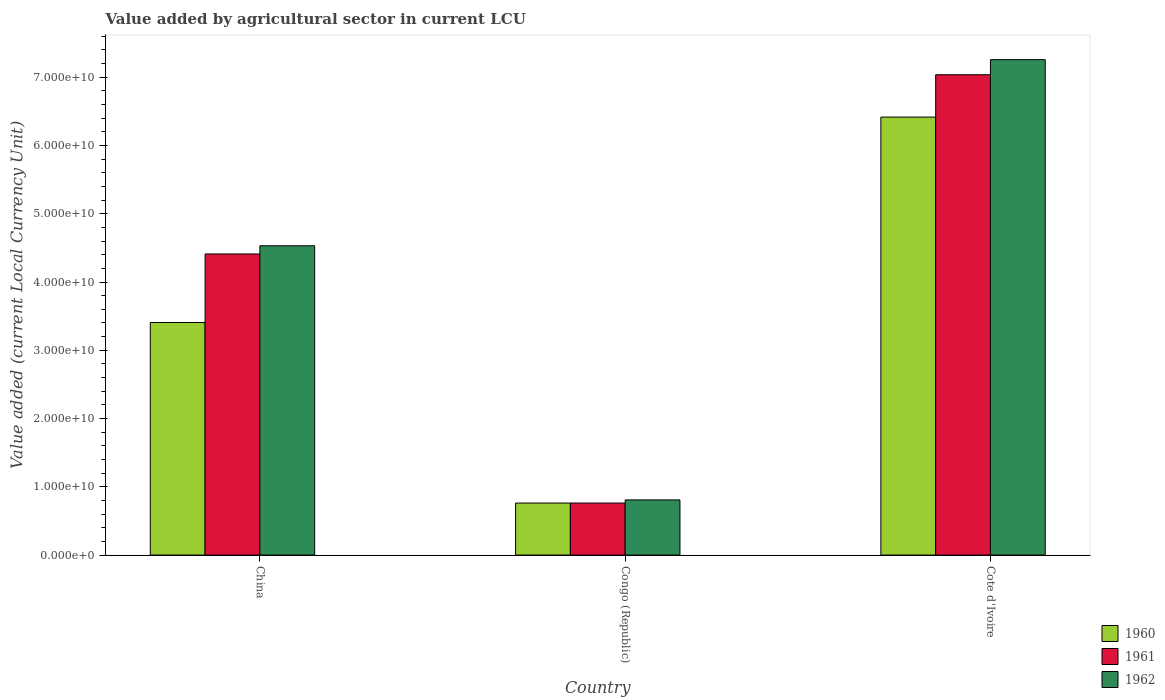How many different coloured bars are there?
Make the answer very short. 3. Are the number of bars per tick equal to the number of legend labels?
Make the answer very short. Yes. Are the number of bars on each tick of the X-axis equal?
Provide a succinct answer. Yes. How many bars are there on the 2nd tick from the right?
Provide a succinct answer. 3. What is the label of the 3rd group of bars from the left?
Your response must be concise. Cote d'Ivoire. In how many cases, is the number of bars for a given country not equal to the number of legend labels?
Ensure brevity in your answer.  0. What is the value added by agricultural sector in 1962 in Cote d'Ivoire?
Give a very brief answer. 7.26e+1. Across all countries, what is the maximum value added by agricultural sector in 1961?
Your answer should be very brief. 7.04e+1. Across all countries, what is the minimum value added by agricultural sector in 1960?
Provide a succinct answer. 7.62e+09. In which country was the value added by agricultural sector in 1961 maximum?
Offer a terse response. Cote d'Ivoire. In which country was the value added by agricultural sector in 1960 minimum?
Your response must be concise. Congo (Republic). What is the total value added by agricultural sector in 1960 in the graph?
Make the answer very short. 1.06e+11. What is the difference between the value added by agricultural sector in 1960 in China and that in Congo (Republic)?
Provide a succinct answer. 2.64e+1. What is the difference between the value added by agricultural sector in 1960 in Congo (Republic) and the value added by agricultural sector in 1961 in Cote d'Ivoire?
Provide a short and direct response. -6.27e+1. What is the average value added by agricultural sector in 1961 per country?
Your response must be concise. 4.07e+1. What is the difference between the value added by agricultural sector of/in 1961 and value added by agricultural sector of/in 1962 in Cote d'Ivoire?
Keep it short and to the point. -2.21e+09. In how many countries, is the value added by agricultural sector in 1961 greater than 36000000000 LCU?
Offer a very short reply. 2. What is the ratio of the value added by agricultural sector in 1961 in China to that in Cote d'Ivoire?
Give a very brief answer. 0.63. Is the difference between the value added by agricultural sector in 1961 in China and Congo (Republic) greater than the difference between the value added by agricultural sector in 1962 in China and Congo (Republic)?
Offer a terse response. No. What is the difference between the highest and the second highest value added by agricultural sector in 1962?
Your response must be concise. 6.45e+1. What is the difference between the highest and the lowest value added by agricultural sector in 1961?
Keep it short and to the point. 6.27e+1. Is the sum of the value added by agricultural sector in 1960 in China and Congo (Republic) greater than the maximum value added by agricultural sector in 1962 across all countries?
Your answer should be compact. No. What does the 1st bar from the left in China represents?
Provide a succinct answer. 1960. Is it the case that in every country, the sum of the value added by agricultural sector in 1962 and value added by agricultural sector in 1961 is greater than the value added by agricultural sector in 1960?
Provide a short and direct response. Yes. Are all the bars in the graph horizontal?
Ensure brevity in your answer.  No. What is the difference between two consecutive major ticks on the Y-axis?
Your response must be concise. 1.00e+1. Where does the legend appear in the graph?
Offer a terse response. Bottom right. What is the title of the graph?
Your answer should be compact. Value added by agricultural sector in current LCU. Does "2004" appear as one of the legend labels in the graph?
Provide a succinct answer. No. What is the label or title of the X-axis?
Keep it short and to the point. Country. What is the label or title of the Y-axis?
Provide a short and direct response. Value added (current Local Currency Unit). What is the Value added (current Local Currency Unit) in 1960 in China?
Provide a succinct answer. 3.41e+1. What is the Value added (current Local Currency Unit) of 1961 in China?
Provide a succinct answer. 4.41e+1. What is the Value added (current Local Currency Unit) of 1962 in China?
Make the answer very short. 4.53e+1. What is the Value added (current Local Currency Unit) of 1960 in Congo (Republic)?
Make the answer very short. 7.62e+09. What is the Value added (current Local Currency Unit) in 1961 in Congo (Republic)?
Give a very brief answer. 7.62e+09. What is the Value added (current Local Currency Unit) of 1962 in Congo (Republic)?
Keep it short and to the point. 8.08e+09. What is the Value added (current Local Currency Unit) of 1960 in Cote d'Ivoire?
Give a very brief answer. 6.42e+1. What is the Value added (current Local Currency Unit) of 1961 in Cote d'Ivoire?
Make the answer very short. 7.04e+1. What is the Value added (current Local Currency Unit) of 1962 in Cote d'Ivoire?
Your response must be concise. 7.26e+1. Across all countries, what is the maximum Value added (current Local Currency Unit) of 1960?
Offer a very short reply. 6.42e+1. Across all countries, what is the maximum Value added (current Local Currency Unit) of 1961?
Keep it short and to the point. 7.04e+1. Across all countries, what is the maximum Value added (current Local Currency Unit) of 1962?
Ensure brevity in your answer.  7.26e+1. Across all countries, what is the minimum Value added (current Local Currency Unit) in 1960?
Your answer should be compact. 7.62e+09. Across all countries, what is the minimum Value added (current Local Currency Unit) of 1961?
Ensure brevity in your answer.  7.62e+09. Across all countries, what is the minimum Value added (current Local Currency Unit) of 1962?
Your response must be concise. 8.08e+09. What is the total Value added (current Local Currency Unit) in 1960 in the graph?
Keep it short and to the point. 1.06e+11. What is the total Value added (current Local Currency Unit) in 1961 in the graph?
Give a very brief answer. 1.22e+11. What is the total Value added (current Local Currency Unit) in 1962 in the graph?
Offer a terse response. 1.26e+11. What is the difference between the Value added (current Local Currency Unit) of 1960 in China and that in Congo (Republic)?
Your answer should be compact. 2.64e+1. What is the difference between the Value added (current Local Currency Unit) in 1961 in China and that in Congo (Republic)?
Give a very brief answer. 3.65e+1. What is the difference between the Value added (current Local Currency Unit) of 1962 in China and that in Congo (Republic)?
Give a very brief answer. 3.72e+1. What is the difference between the Value added (current Local Currency Unit) in 1960 in China and that in Cote d'Ivoire?
Your response must be concise. -3.01e+1. What is the difference between the Value added (current Local Currency Unit) of 1961 in China and that in Cote d'Ivoire?
Provide a short and direct response. -2.63e+1. What is the difference between the Value added (current Local Currency Unit) in 1962 in China and that in Cote d'Ivoire?
Give a very brief answer. -2.73e+1. What is the difference between the Value added (current Local Currency Unit) in 1960 in Congo (Republic) and that in Cote d'Ivoire?
Your response must be concise. -5.65e+1. What is the difference between the Value added (current Local Currency Unit) in 1961 in Congo (Republic) and that in Cote d'Ivoire?
Your answer should be very brief. -6.27e+1. What is the difference between the Value added (current Local Currency Unit) in 1962 in Congo (Republic) and that in Cote d'Ivoire?
Give a very brief answer. -6.45e+1. What is the difference between the Value added (current Local Currency Unit) in 1960 in China and the Value added (current Local Currency Unit) in 1961 in Congo (Republic)?
Offer a very short reply. 2.64e+1. What is the difference between the Value added (current Local Currency Unit) of 1960 in China and the Value added (current Local Currency Unit) of 1962 in Congo (Republic)?
Ensure brevity in your answer.  2.60e+1. What is the difference between the Value added (current Local Currency Unit) of 1961 in China and the Value added (current Local Currency Unit) of 1962 in Congo (Republic)?
Give a very brief answer. 3.60e+1. What is the difference between the Value added (current Local Currency Unit) of 1960 in China and the Value added (current Local Currency Unit) of 1961 in Cote d'Ivoire?
Provide a succinct answer. -3.63e+1. What is the difference between the Value added (current Local Currency Unit) in 1960 in China and the Value added (current Local Currency Unit) in 1962 in Cote d'Ivoire?
Ensure brevity in your answer.  -3.85e+1. What is the difference between the Value added (current Local Currency Unit) of 1961 in China and the Value added (current Local Currency Unit) of 1962 in Cote d'Ivoire?
Ensure brevity in your answer.  -2.85e+1. What is the difference between the Value added (current Local Currency Unit) of 1960 in Congo (Republic) and the Value added (current Local Currency Unit) of 1961 in Cote d'Ivoire?
Your answer should be very brief. -6.27e+1. What is the difference between the Value added (current Local Currency Unit) of 1960 in Congo (Republic) and the Value added (current Local Currency Unit) of 1962 in Cote d'Ivoire?
Keep it short and to the point. -6.50e+1. What is the difference between the Value added (current Local Currency Unit) of 1961 in Congo (Republic) and the Value added (current Local Currency Unit) of 1962 in Cote d'Ivoire?
Give a very brief answer. -6.50e+1. What is the average Value added (current Local Currency Unit) in 1960 per country?
Offer a terse response. 3.53e+1. What is the average Value added (current Local Currency Unit) in 1961 per country?
Your response must be concise. 4.07e+1. What is the average Value added (current Local Currency Unit) of 1962 per country?
Your answer should be compact. 4.20e+1. What is the difference between the Value added (current Local Currency Unit) of 1960 and Value added (current Local Currency Unit) of 1961 in China?
Your answer should be very brief. -1.00e+1. What is the difference between the Value added (current Local Currency Unit) in 1960 and Value added (current Local Currency Unit) in 1962 in China?
Provide a succinct answer. -1.12e+1. What is the difference between the Value added (current Local Currency Unit) of 1961 and Value added (current Local Currency Unit) of 1962 in China?
Keep it short and to the point. -1.20e+09. What is the difference between the Value added (current Local Currency Unit) in 1960 and Value added (current Local Currency Unit) in 1962 in Congo (Republic)?
Offer a very short reply. -4.57e+08. What is the difference between the Value added (current Local Currency Unit) in 1961 and Value added (current Local Currency Unit) in 1962 in Congo (Republic)?
Provide a short and direct response. -4.57e+08. What is the difference between the Value added (current Local Currency Unit) of 1960 and Value added (current Local Currency Unit) of 1961 in Cote d'Ivoire?
Give a very brief answer. -6.21e+09. What is the difference between the Value added (current Local Currency Unit) in 1960 and Value added (current Local Currency Unit) in 1962 in Cote d'Ivoire?
Your answer should be compact. -8.41e+09. What is the difference between the Value added (current Local Currency Unit) of 1961 and Value added (current Local Currency Unit) of 1962 in Cote d'Ivoire?
Offer a very short reply. -2.21e+09. What is the ratio of the Value added (current Local Currency Unit) in 1960 in China to that in Congo (Republic)?
Ensure brevity in your answer.  4.47. What is the ratio of the Value added (current Local Currency Unit) of 1961 in China to that in Congo (Republic)?
Keep it short and to the point. 5.79. What is the ratio of the Value added (current Local Currency Unit) of 1962 in China to that in Congo (Republic)?
Provide a succinct answer. 5.61. What is the ratio of the Value added (current Local Currency Unit) of 1960 in China to that in Cote d'Ivoire?
Give a very brief answer. 0.53. What is the ratio of the Value added (current Local Currency Unit) in 1961 in China to that in Cote d'Ivoire?
Provide a short and direct response. 0.63. What is the ratio of the Value added (current Local Currency Unit) in 1962 in China to that in Cote d'Ivoire?
Keep it short and to the point. 0.62. What is the ratio of the Value added (current Local Currency Unit) in 1960 in Congo (Republic) to that in Cote d'Ivoire?
Give a very brief answer. 0.12. What is the ratio of the Value added (current Local Currency Unit) of 1961 in Congo (Republic) to that in Cote d'Ivoire?
Your answer should be compact. 0.11. What is the ratio of the Value added (current Local Currency Unit) in 1962 in Congo (Republic) to that in Cote d'Ivoire?
Provide a short and direct response. 0.11. What is the difference between the highest and the second highest Value added (current Local Currency Unit) in 1960?
Ensure brevity in your answer.  3.01e+1. What is the difference between the highest and the second highest Value added (current Local Currency Unit) of 1961?
Make the answer very short. 2.63e+1. What is the difference between the highest and the second highest Value added (current Local Currency Unit) of 1962?
Your response must be concise. 2.73e+1. What is the difference between the highest and the lowest Value added (current Local Currency Unit) of 1960?
Ensure brevity in your answer.  5.65e+1. What is the difference between the highest and the lowest Value added (current Local Currency Unit) of 1961?
Offer a very short reply. 6.27e+1. What is the difference between the highest and the lowest Value added (current Local Currency Unit) of 1962?
Keep it short and to the point. 6.45e+1. 